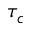<formula> <loc_0><loc_0><loc_500><loc_500>\tau _ { c }</formula> 